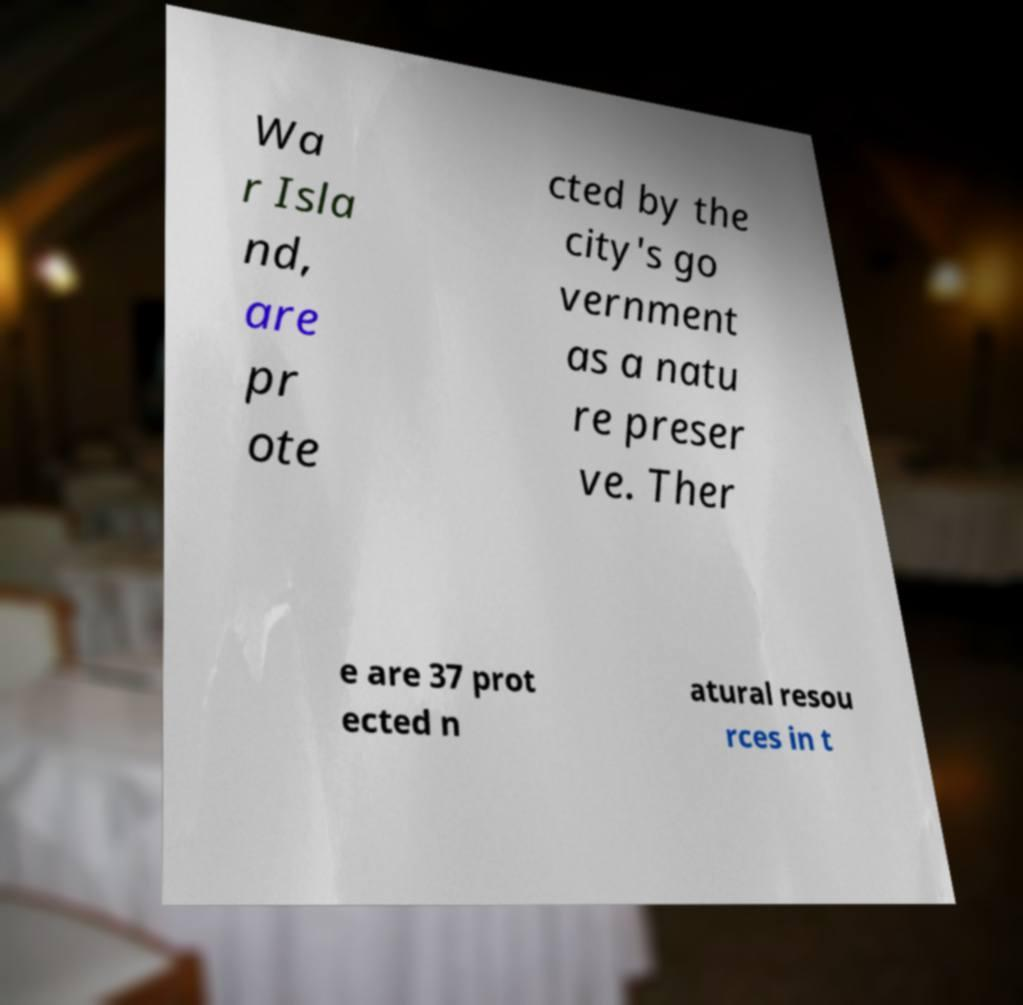Could you assist in decoding the text presented in this image and type it out clearly? Wa r Isla nd, are pr ote cted by the city's go vernment as a natu re preser ve. Ther e are 37 prot ected n atural resou rces in t 